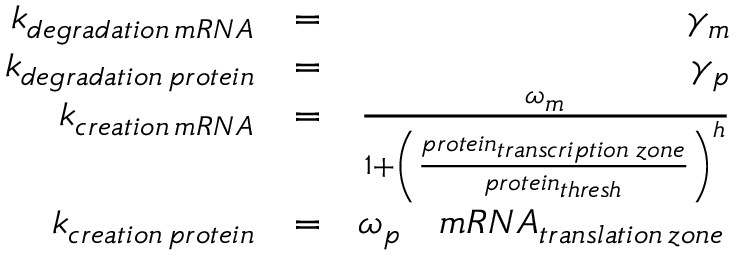<formula> <loc_0><loc_0><loc_500><loc_500>\begin{array} { r l r } { k _ { d e g r a d a t i o n \, m R N A } } & { = } & { \gamma _ { m } } \\ { k _ { d e g r a d a t i o n \, p r o t e i n } } & { = } & { \gamma _ { p } } \\ { k _ { c r e a t i o n \, m R N A } } & { = } & { \frac { \omega _ { m } } { 1 + \left ( \frac { p r o t e i n _ { t r a n s c r i p t i o n \, z o n e } } { p r o t e i n _ { t h r e s h } } \right ) ^ { h } } } \\ { k _ { c r e a t i o n \, p r o t e i n } } & { = } & { \omega _ { p } \quad m R N A _ { t r a n s l a t i o n \, z o n e } \, } \end{array}</formula> 